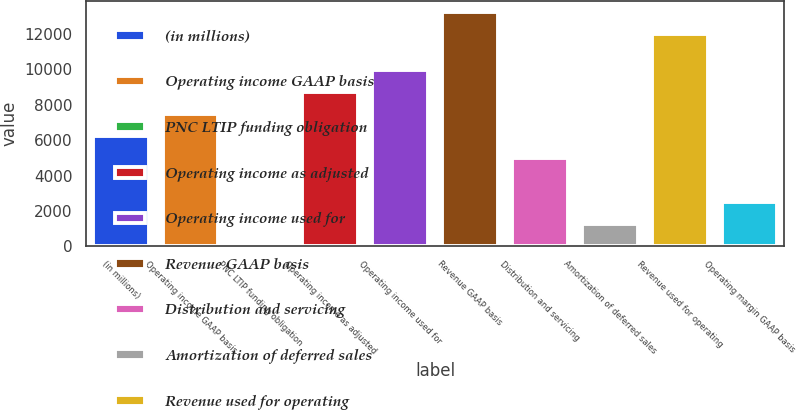<chart> <loc_0><loc_0><loc_500><loc_500><bar_chart><fcel>(in millions)<fcel>Operating income GAAP basis<fcel>PNC LTIP funding obligation<fcel>Operating income as adjusted<fcel>Operating income used for<fcel>Revenue GAAP basis<fcel>Distribution and servicing<fcel>Amortization of deferred sales<fcel>Revenue used for operating<fcel>Operating margin GAAP basis<nl><fcel>6253<fcel>7500.6<fcel>15<fcel>8748.2<fcel>9995.8<fcel>13229.6<fcel>5005.4<fcel>1262.6<fcel>11982<fcel>2510.2<nl></chart> 